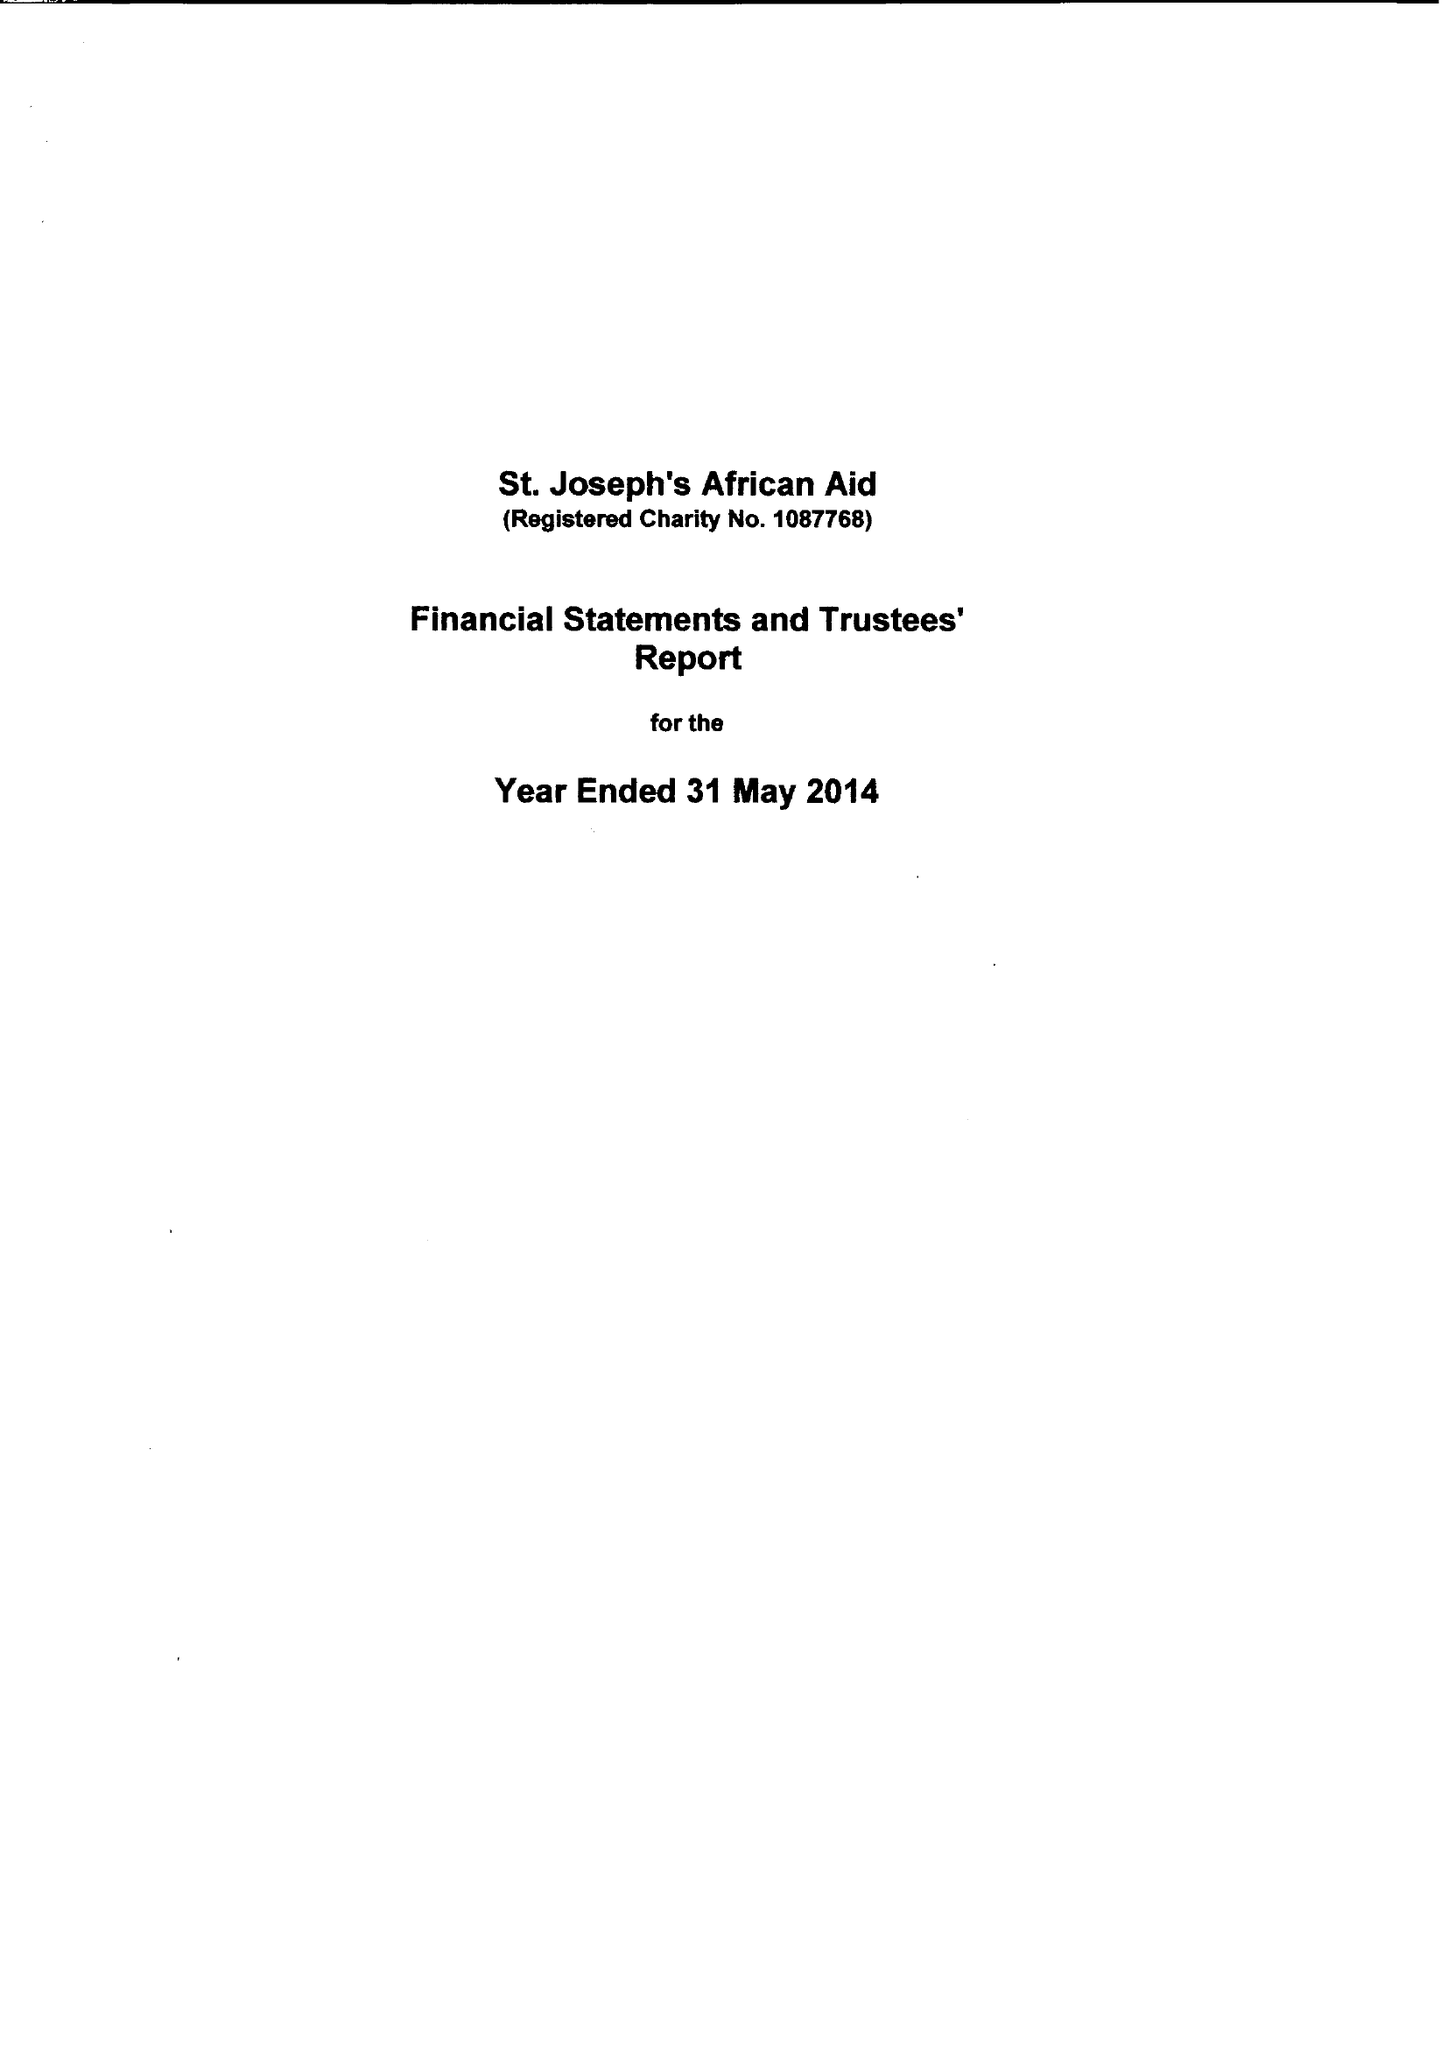What is the value for the address__street_line?
Answer the question using a single word or phrase. 131 HORTON ROAD 